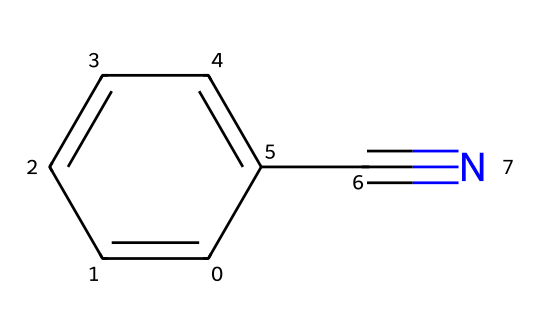What is the main functional group in benzonitrile? The main functional group in benzonitrile is the nitrile group, which is characterized by the carbon triple-bonded to a nitrogen atom (C#N).
Answer: nitrile How many carbon atoms are in benzonitrile? In the SMILES representation, there are six carbon atoms in the phenyl ring and one additional carbon in the nitrile group, totaling seven carbon atoms.
Answer: seven What is the molecular formula of benzonitrile? The molecular formula can be determined by counting the atoms in the structure; there are seven carbons, five hydrogens, and one nitrogen, resulting in C7H5N.
Answer: C7H5N Does benzonitrile contain any functional groups besides nitrile? The structure shows a phenyl ring, which serves as an aromatic functional group, but no other functional groups are present.
Answer: no What type of isomer is benzonitrile? Benzonitrile is a structural isomer because its nitrile group is attached to a phenyl ring, differing in connectivity from other isomers with the same molecular formula.
Answer: structural isomer Why might benzonitrile be used in neurological medications? Benzonitrile has properties that may influence nervous system functions; its ability to cross the blood-brain barrier and its derivatives could modulate neurotransmitter activity.
Answer: properties that influence nervous system functions 